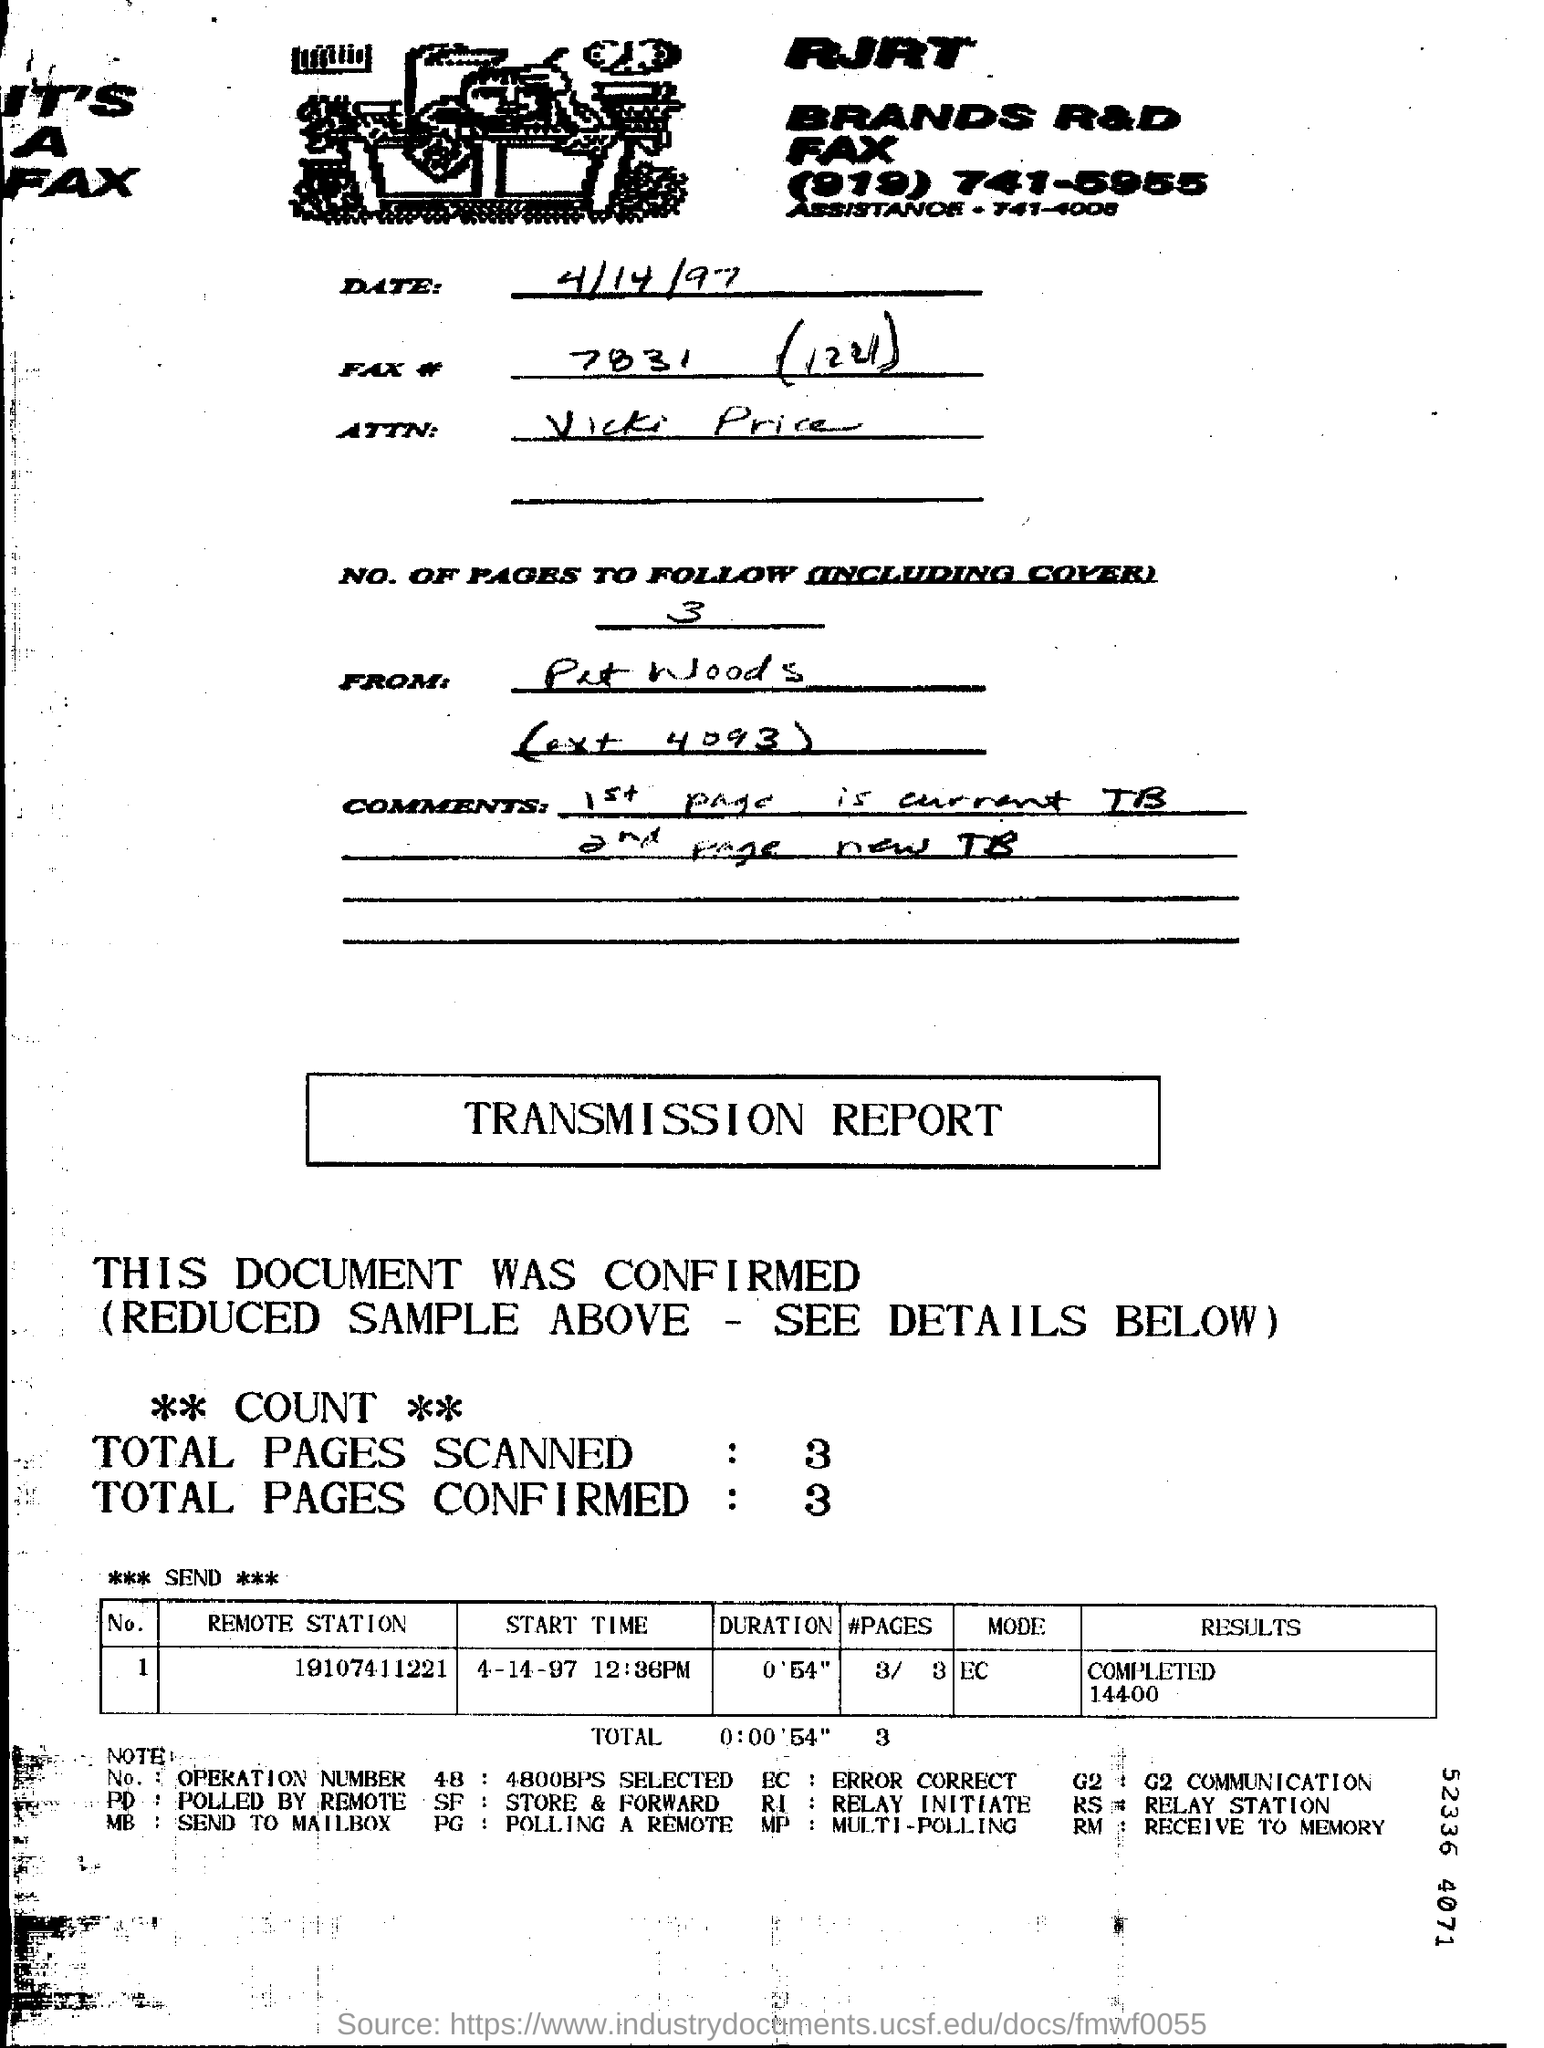HOW MANY NUMBER OF PAGES INCLUDING THE COVER?
Your answer should be very brief. 3. WHAT IS THE EXT NUMBER OF PAT WOODS?
Ensure brevity in your answer.  4093. WHICH PAGE IS THE NEW TB?
Your answer should be very brief. 2ND PAGE. HOW MUCH IS THE TOTAL PAGES SCANNED?
Make the answer very short. 3. WHAT IS THE RESULT IN TRANSMISSION REPORT?
Your response must be concise. COMPLETED 14400. 